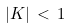<formula> <loc_0><loc_0><loc_500><loc_500>| K | \, < \, 1</formula> 